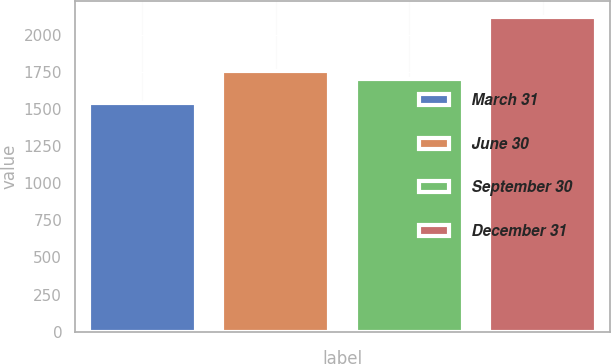Convert chart to OTSL. <chart><loc_0><loc_0><loc_500><loc_500><bar_chart><fcel>March 31<fcel>June 30<fcel>September 30<fcel>December 31<nl><fcel>1543<fcel>1758.37<fcel>1700.4<fcel>2122.7<nl></chart> 